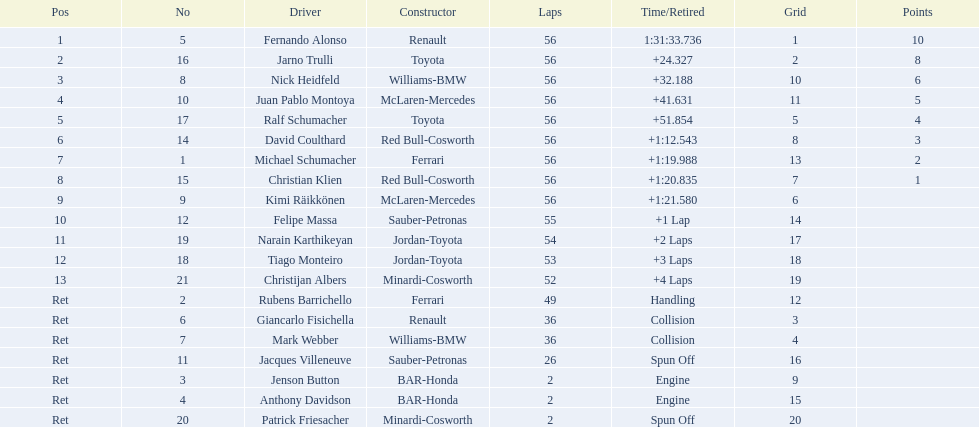Can you parse all the data within this table? {'header': ['Pos', 'No', 'Driver', 'Constructor', 'Laps', 'Time/Retired', 'Grid', 'Points'], 'rows': [['1', '5', 'Fernando Alonso', 'Renault', '56', '1:31:33.736', '1', '10'], ['2', '16', 'Jarno Trulli', 'Toyota', '56', '+24.327', '2', '8'], ['3', '8', 'Nick Heidfeld', 'Williams-BMW', '56', '+32.188', '10', '6'], ['4', '10', 'Juan Pablo Montoya', 'McLaren-Mercedes', '56', '+41.631', '11', '5'], ['5', '17', 'Ralf Schumacher', 'Toyota', '56', '+51.854', '5', '4'], ['6', '14', 'David Coulthard', 'Red Bull-Cosworth', '56', '+1:12.543', '8', '3'], ['7', '1', 'Michael Schumacher', 'Ferrari', '56', '+1:19.988', '13', '2'], ['8', '15', 'Christian Klien', 'Red Bull-Cosworth', '56', '+1:20.835', '7', '1'], ['9', '9', 'Kimi Räikkönen', 'McLaren-Mercedes', '56', '+1:21.580', '6', ''], ['10', '12', 'Felipe Massa', 'Sauber-Petronas', '55', '+1 Lap', '14', ''], ['11', '19', 'Narain Karthikeyan', 'Jordan-Toyota', '54', '+2 Laps', '17', ''], ['12', '18', 'Tiago Monteiro', 'Jordan-Toyota', '53', '+3 Laps', '18', ''], ['13', '21', 'Christijan Albers', 'Minardi-Cosworth', '52', '+4 Laps', '19', ''], ['Ret', '2', 'Rubens Barrichello', 'Ferrari', '49', 'Handling', '12', ''], ['Ret', '6', 'Giancarlo Fisichella', 'Renault', '36', 'Collision', '3', ''], ['Ret', '7', 'Mark Webber', 'Williams-BMW', '36', 'Collision', '4', ''], ['Ret', '11', 'Jacques Villeneuve', 'Sauber-Petronas', '26', 'Spun Off', '16', ''], ['Ret', '3', 'Jenson Button', 'BAR-Honda', '2', 'Engine', '9', ''], ['Ret', '4', 'Anthony Davidson', 'BAR-Honda', '2', 'Engine', '15', ''], ['Ret', '20', 'Patrick Friesacher', 'Minardi-Cosworth', '2', 'Spun Off', '20', '']]} Who trained fernando alonso? Renault. What is the count of laps that alonso finished? 56. How much time did alonso spend to finish the race? 1:31:33.736. 